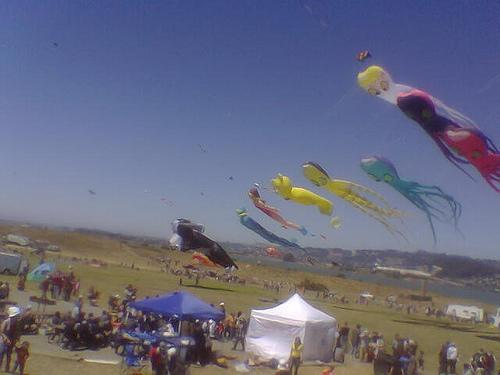What type of structures are shown?

Choices:
A) home
B) tent
C) hotel
D) garage tent 